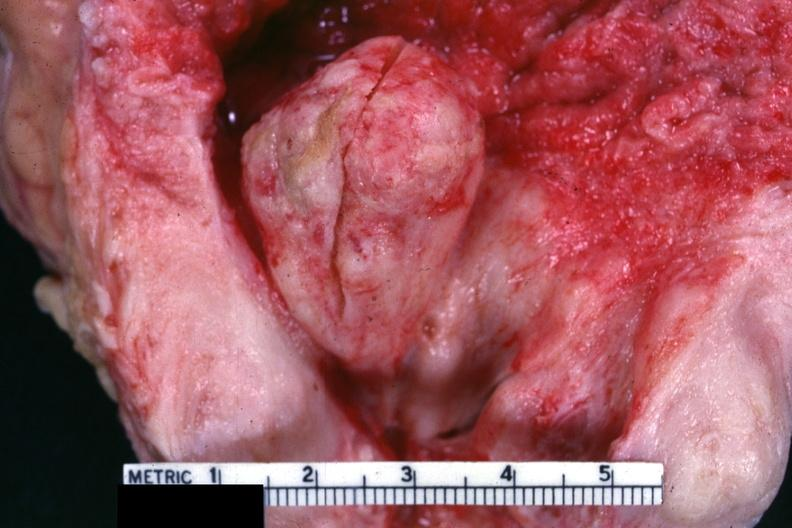does this image show close-up view of large median lobe extending into floor of bladder?
Answer the question using a single word or phrase. Yes 